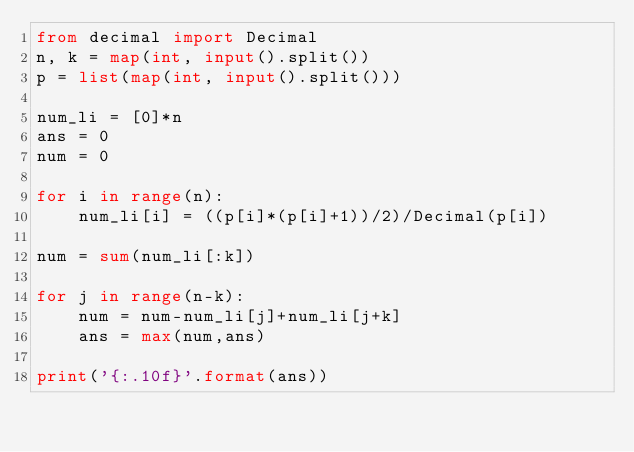<code> <loc_0><loc_0><loc_500><loc_500><_Python_>from decimal import Decimal
n, k = map(int, input().split())
p = list(map(int, input().split()))

num_li = [0]*n
ans = 0
num = 0

for i in range(n):
    num_li[i] = ((p[i]*(p[i]+1))/2)/Decimal(p[i])

num = sum(num_li[:k])

for j in range(n-k):
    num = num-num_li[j]+num_li[j+k]
    ans = max(num,ans)

print('{:.10f}'.format(ans))</code> 